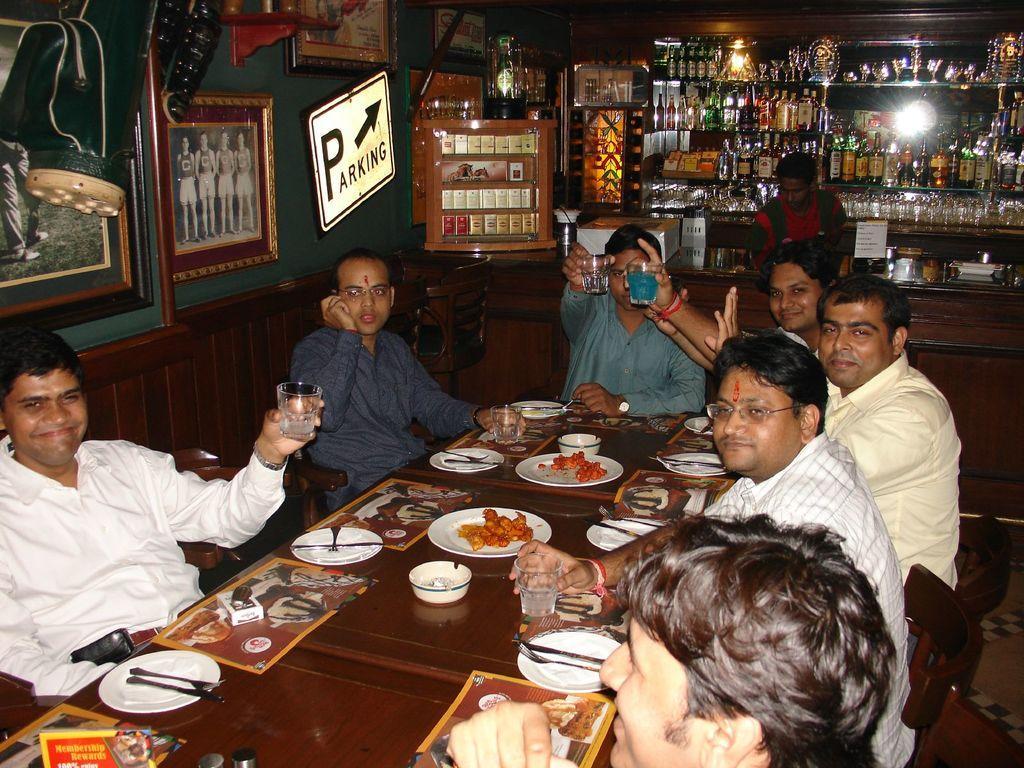How would you summarize this image in a sentence or two? In this image we can see some people and there is a table in front of them and on the table, we can see plates, bowls and food items and it looks like a restaurant. We can see some photo frames attached to the wall and there is a rack with some bottles, glasses and some other objects. 